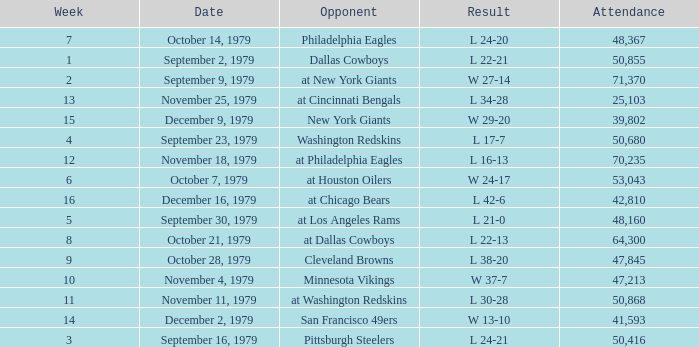What result in a week over 2 occurred with an attendance greater than 53,043 on November 18, 1979? L 16-13. 